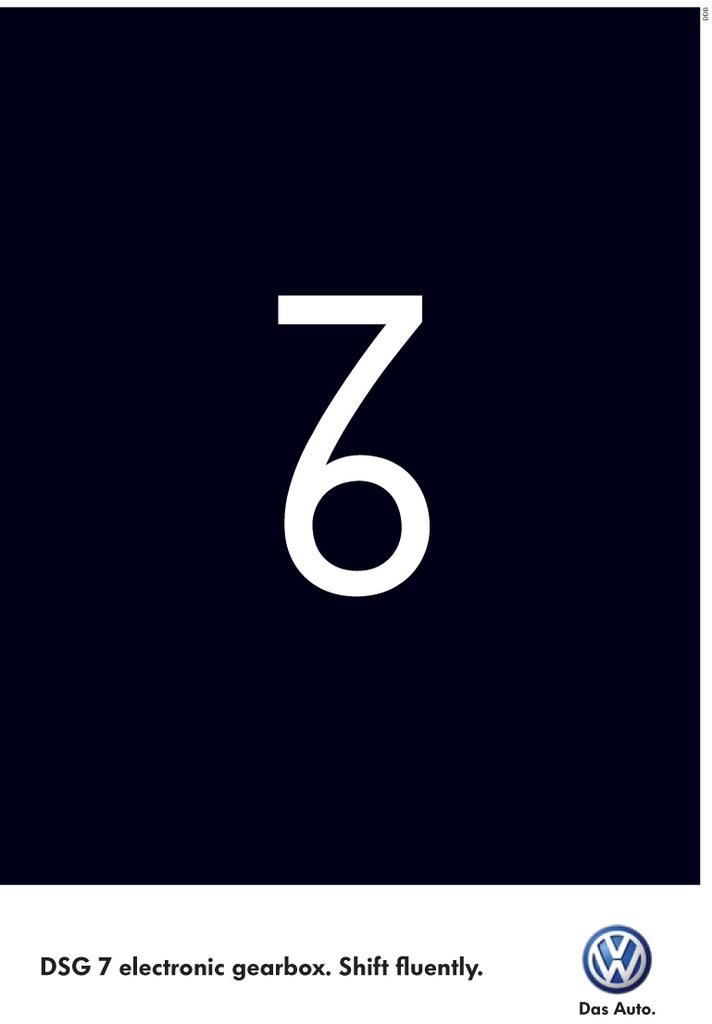Provide a one-sentence caption for the provided image. A VW poster with a 7 attached to a 6 to make a weird looking glyph. 